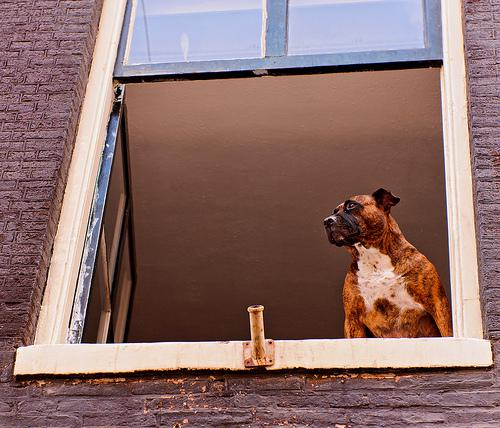Question: where is this picture taken?
Choices:
A. Above window.
B. To the right of the window.
C. Below window.
D. To the left of the window.
Answer with the letter. Answer: C Question: what time of day is it?
Choices:
A. Morning.
B. Afternoon.
C. Evening.
D. Night.
Answer with the letter. Answer: A Question: what color is the dog?
Choices:
A. Beige.
B. Golden.
C. Black.
D. Brown and white.
Answer with the letter. Answer: D Question: what color is the window?
Choices:
A. Beige.
B. Yellow.
C. White.
D. Golden.
Answer with the letter. Answer: A 